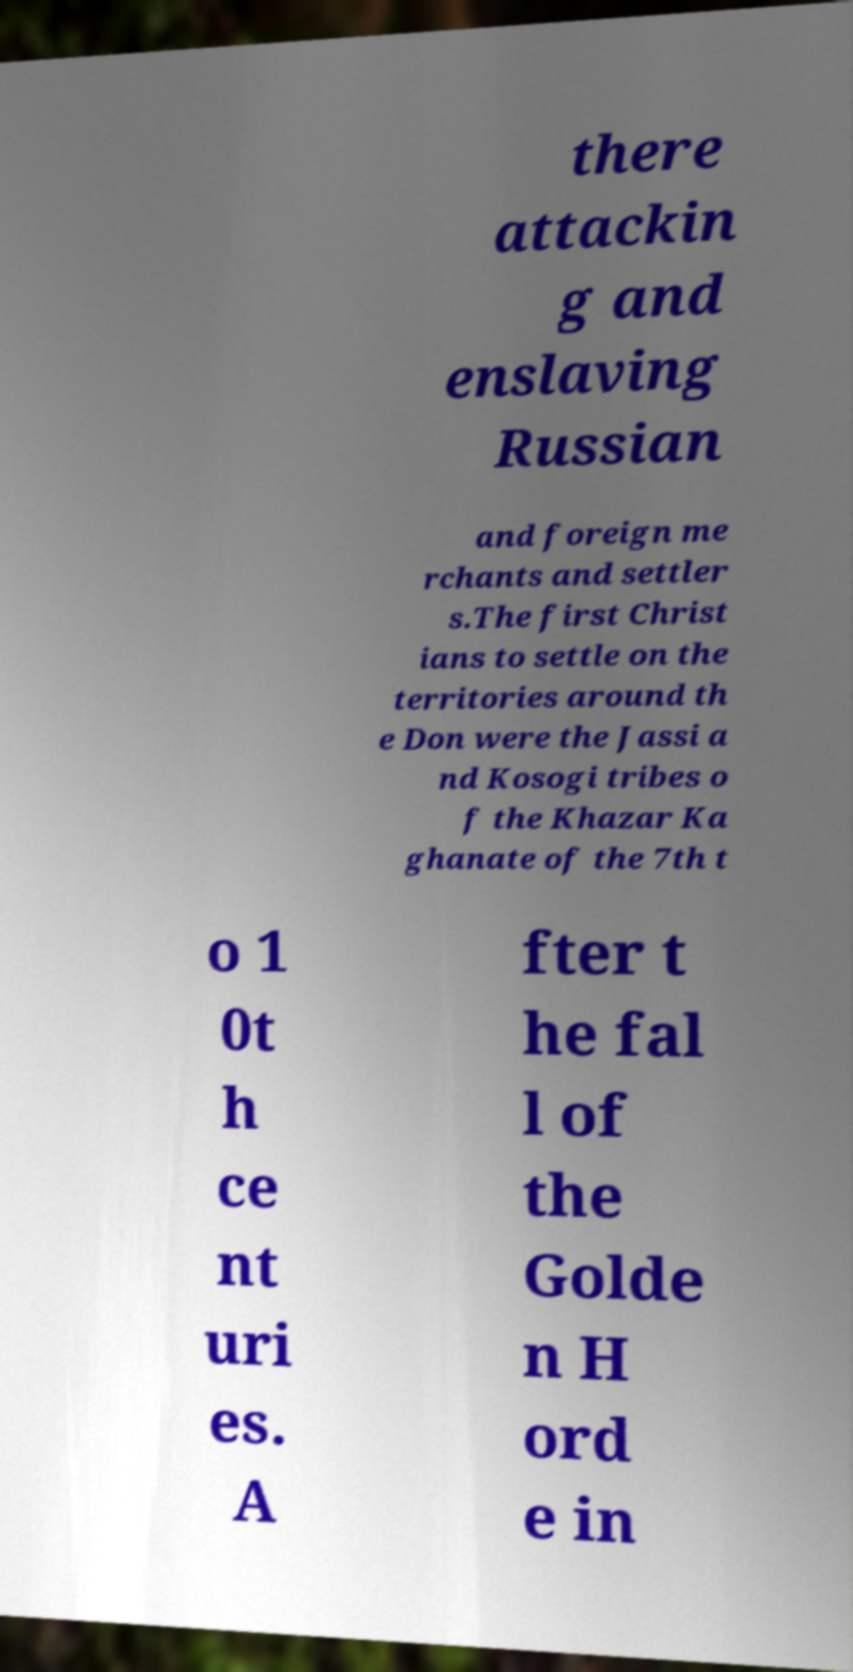Can you accurately transcribe the text from the provided image for me? there attackin g and enslaving Russian and foreign me rchants and settler s.The first Christ ians to settle on the territories around th e Don were the Jassi a nd Kosogi tribes o f the Khazar Ka ghanate of the 7th t o 1 0t h ce nt uri es. A fter t he fal l of the Golde n H ord e in 